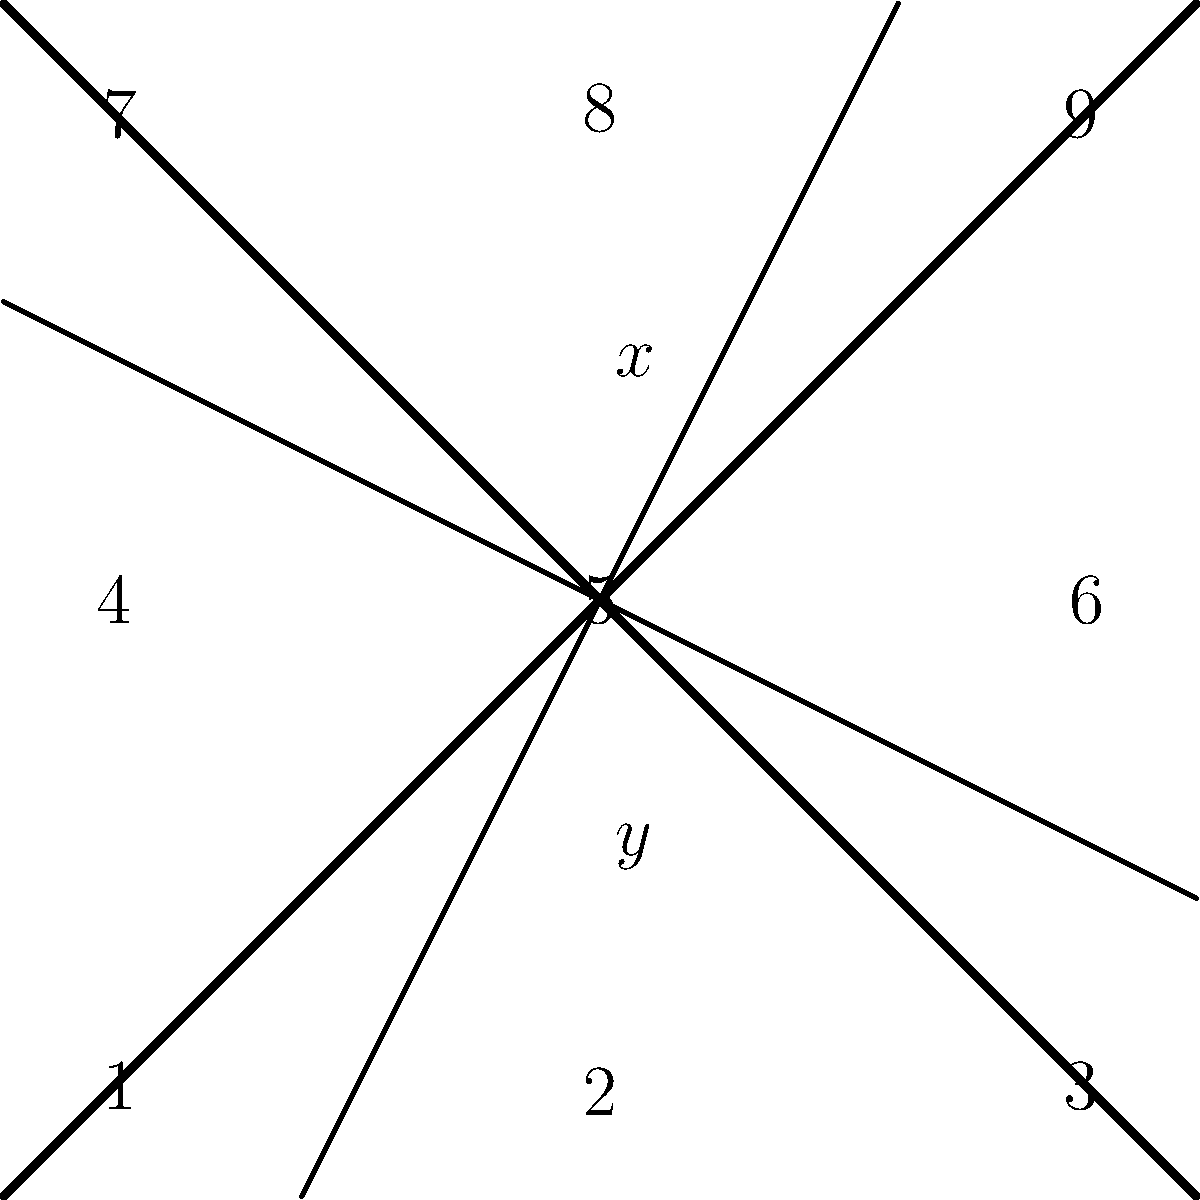In your latest football-themed comic strip, you've divided a panel into a 3x3 grid using intersecting lines. Two angles formed at the center of the grid are labeled $x°$ and $y°$. If the sum of these two angles is 180°, what is the value of $x$ in terms of $y$? Let's approach this step-by-step:

1) First, recall that when two straight lines intersect, they form four angles. The angles directly opposite each other (called vertical angles) are always equal.

2) In our grid, we can see that angles $x°$ and $y°$ are adjacent angles formed by the intersecting lines.

3) We're given that the sum of these two angles is 180°. This is a key piece of information, as it tells us that $x°$ and $y°$ are supplementary angles.

4) The relationship between supplementary angles can be expressed mathematically as:

   $$x + y = 180$$

5) To express $x$ in terms of $y$, we need to isolate $x$ on one side of the equation:

   $$x = 180 - y$$

This equation tells us that $x$ is equal to 180° minus whatever value $y$ has.
Answer: $x = 180 - y$ 